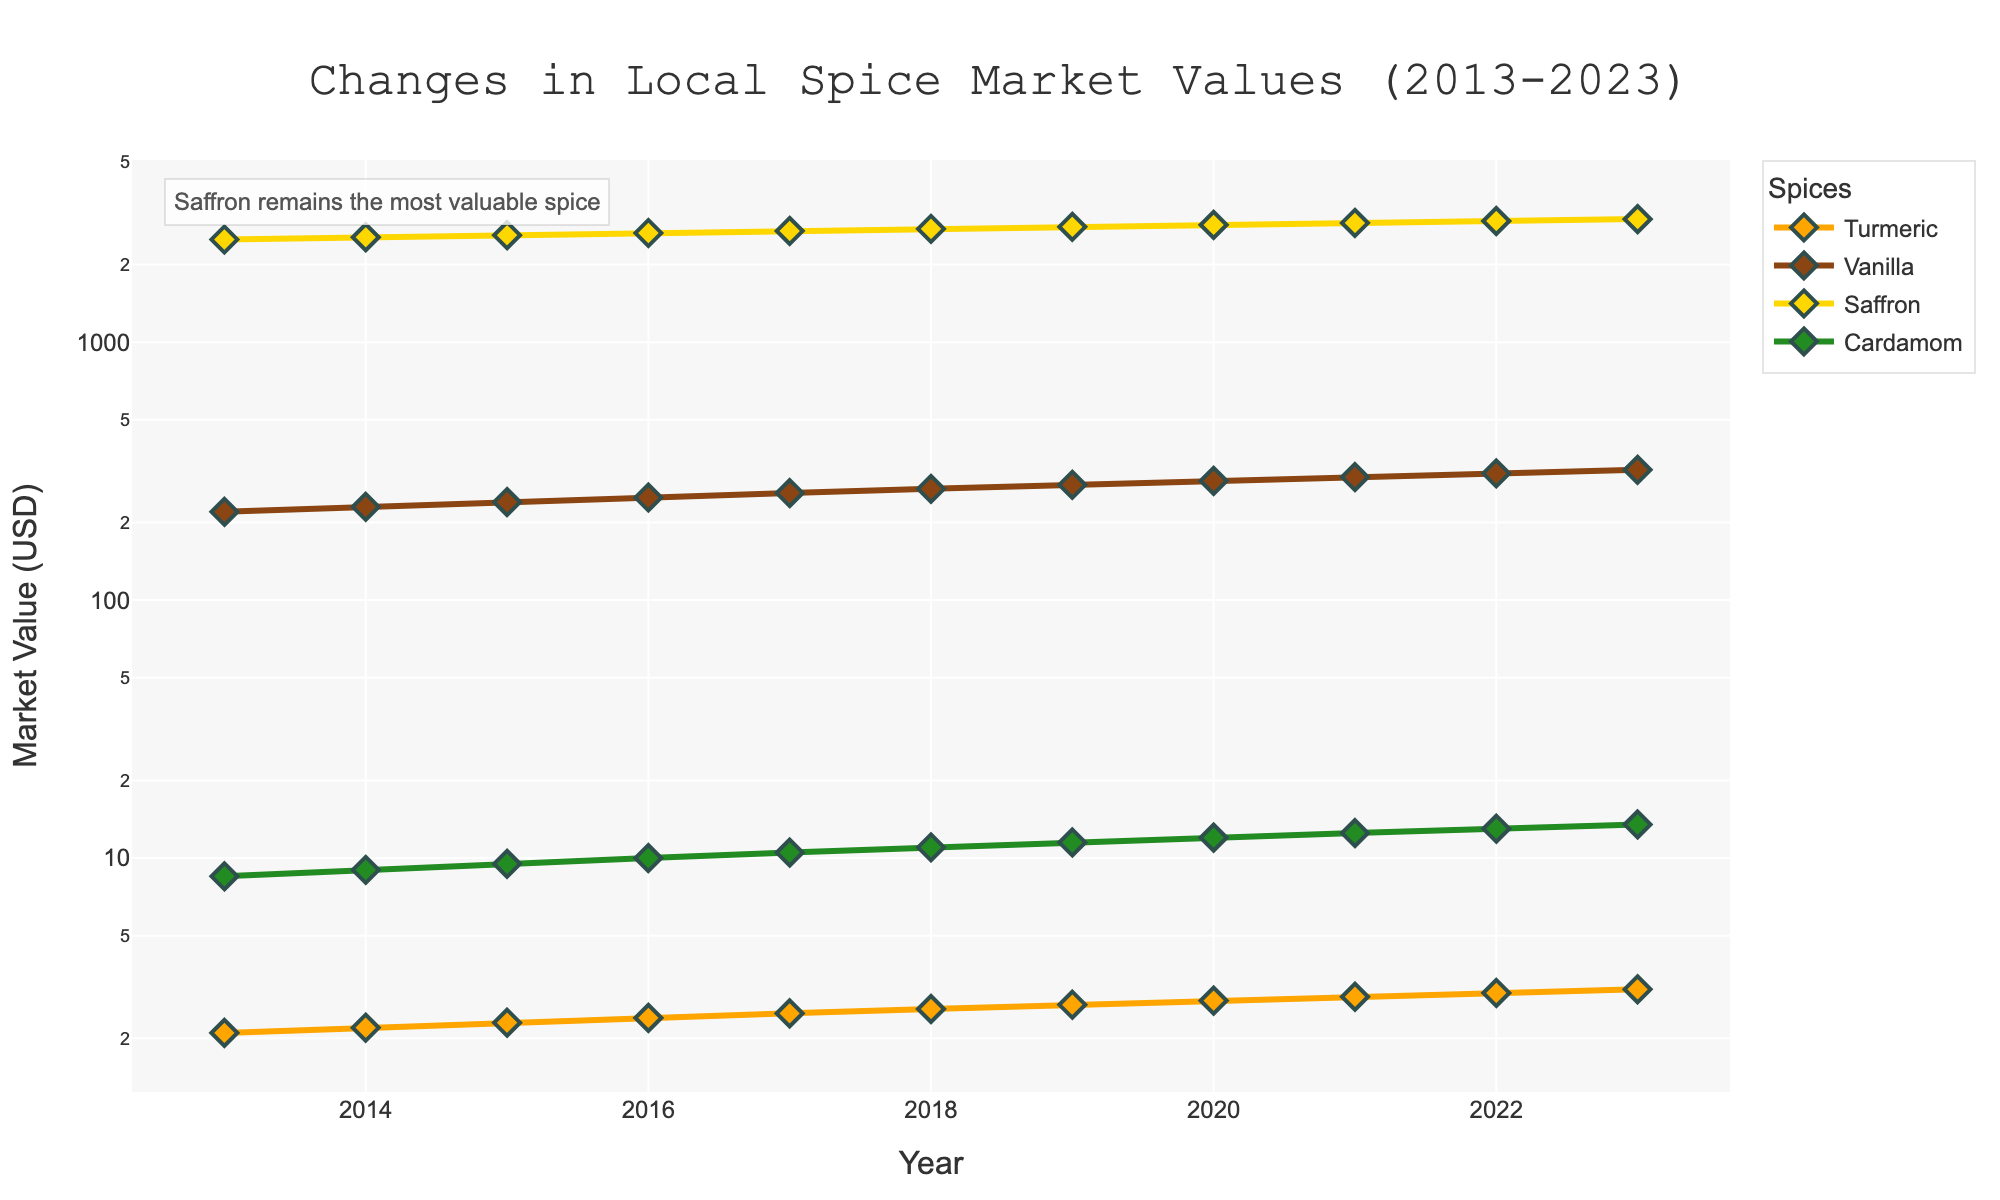What is the title of the figure? The title of the figure can be found at the top of the plot and often gives a general description of what the plot is about. In this case, based on the provided data and code, the title is "Changes in Local Spice Market Values (2013-2023)."
Answer: Changes in Local Spice Market Values (2013-2023) Which spice has the highest market value in 2023? To determine which spice has the highest market value in 2023, check the data points for each spice in that particular year. Saffron's market value is the highest at $3000.00 in 2023.
Answer: Saffron How did the market value of vanilla change from 2013 to 2023? Look at the market value of vanilla in 2013, which is $220.00, and compare it with its market value in 2023, which is $320.00. The market value of vanilla increased by $100.00 over this period.
Answer: Increased by $100.00 What is the average market value of cardamom over the decade? To find the average market value of cardamom over the decade, sum the yearly market values from 2013 to 2023 and then divide by the number of years (11). (8.50 + 9.00 + 9.50 + 10.00 + 10.50 + 11.00 + 11.50 + 12.00 + 12.50 + 13.00 + 13.50) / 11 = 111.00 / 11
Answer: $10.09 Which spice exhibited the most consistent increase in market value across the years? Examine the trend lines for each spice in the figure. Turmeric shows a consistent, steady increase in market value each year from 2013 to 2023, without any drops or plateaus.
Answer: Turmeric Compare the trend in market values between saffron and cardamom. Which spice experienced greater volatility? Saffron's market value started at $2500.00 in 2013 and reached $3000.00 in 2023 with steady increases. Cardamom's value increased steadily but in smaller increments, starting at $8.50 and reaching $13.50. Saffron exhibited greater volatility due to the larger absolute differences in market values.
Answer: Saffron In which year did the market value of turmeric cross 3 USD? Check the yearly market values of turmeric in the data. Turmeric first crossed the 3 USD mark in 2022.
Answer: 2022 Describe the change in saffron's market value from 2018 to 2020. Saffron's market value in 2018 was $2750.00. It increased to $2800.00 in 2019 and further to $2850.00 in 2020. The market value shows a continuous upward trend in these years.
Answer: Continuous Increase How does the market value of cardamom in 2023 compare to that in 2016? Cardamom had a market value of $10.00 in 2016 and $13.50 in 2023. To compare, subtract the 2016 value from the 2023 value: 13.50 - 10.00 = 3.50. Cardamom's market value increased by $3.50.
Answer: Increased by $3.50 Which spice had the highest relative increase in market value over the decade? To find the relative increase for each spice, calculate the percentage increase from 2013 to 2023. The formula is (final value - initial value) / initial value * 100. Saffron: (3000 - 2500) / 2500 * 100 = 20%; Vanilla: (320 - 220) / 220 * 100 = 45.45%; Turmeric: (3.10 - 2.10) / 2.10 * 100 = 47.62%; Cardamom: (13.50 - 8.50) / 8.50 * 100 = 58.82%. Cardamom had the highest relative increase.
Answer: Cardamom 